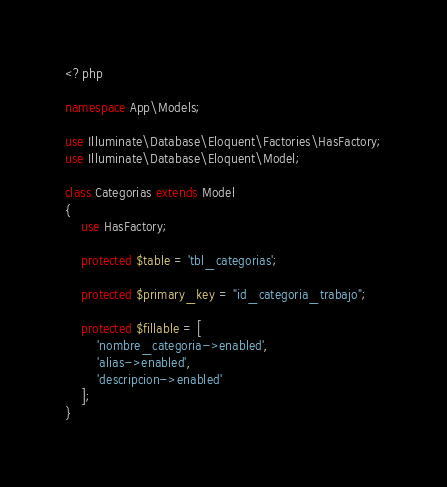<code> <loc_0><loc_0><loc_500><loc_500><_PHP_><?php

namespace App\Models;

use Illuminate\Database\Eloquent\Factories\HasFactory;
use Illuminate\Database\Eloquent\Model;

class Categorias extends Model
{
    use HasFactory;

    protected $table = 'tbl_categorias';
    
    protected $primary_key = "id_categoria_trabajo";

    protected $fillable = [
        'nombre_categoria->enabled',
        'alias->enabled',
        'descripcion->enabled'
    ];
}
</code> 